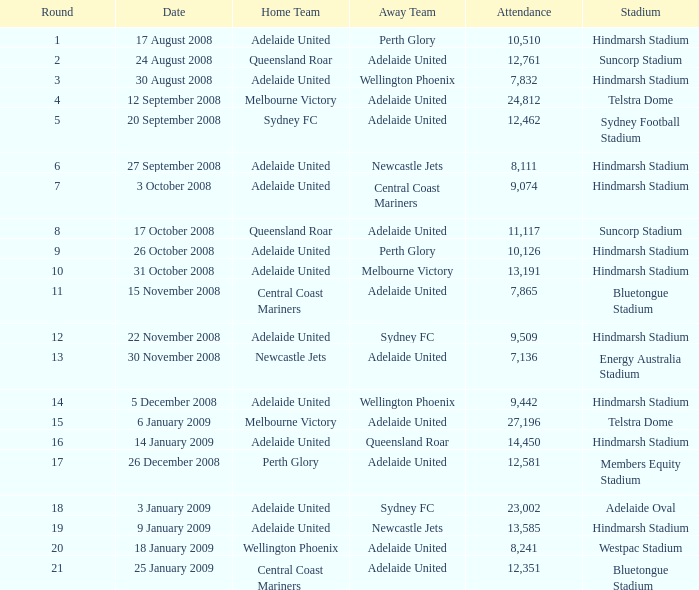When queensland roar was the home team in a round under 3, who were the guests competing against them? Adelaide United. 